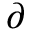<formula> <loc_0><loc_0><loc_500><loc_500>\partial</formula> 